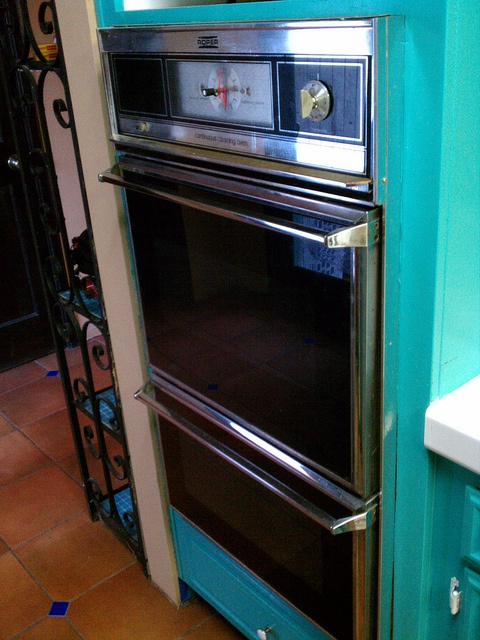Describe the objects in this image and their specific colors. I can see a oven in black, gray, maroon, and navy tones in this image. 